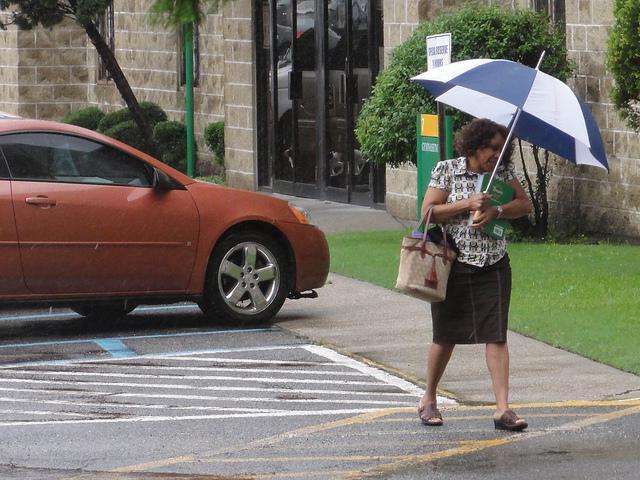How many umbrellas are there?
Give a very brief answer. 1. How many handbags are in the photo?
Give a very brief answer. 1. How many people are on their laptop in this image?
Give a very brief answer. 0. 